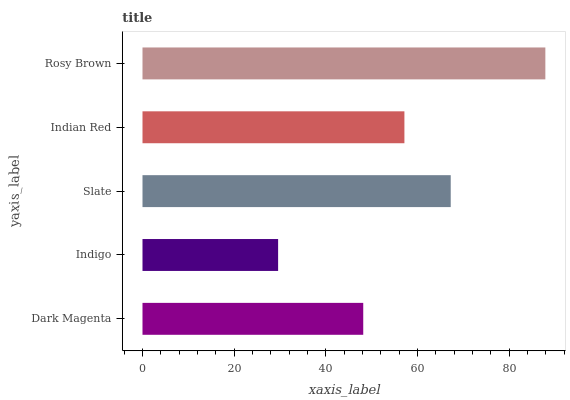Is Indigo the minimum?
Answer yes or no. Yes. Is Rosy Brown the maximum?
Answer yes or no. Yes. Is Slate the minimum?
Answer yes or no. No. Is Slate the maximum?
Answer yes or no. No. Is Slate greater than Indigo?
Answer yes or no. Yes. Is Indigo less than Slate?
Answer yes or no. Yes. Is Indigo greater than Slate?
Answer yes or no. No. Is Slate less than Indigo?
Answer yes or no. No. Is Indian Red the high median?
Answer yes or no. Yes. Is Indian Red the low median?
Answer yes or no. Yes. Is Dark Magenta the high median?
Answer yes or no. No. Is Slate the low median?
Answer yes or no. No. 